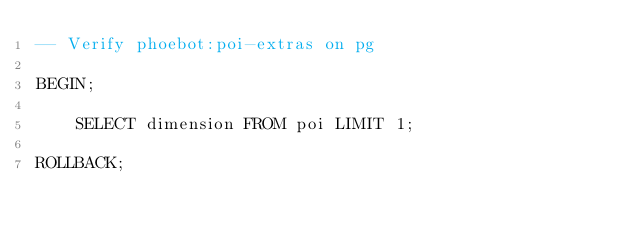<code> <loc_0><loc_0><loc_500><loc_500><_SQL_>-- Verify phoebot:poi-extras on pg

BEGIN;

    SELECT dimension FROM poi LIMIT 1;

ROLLBACK;
</code> 